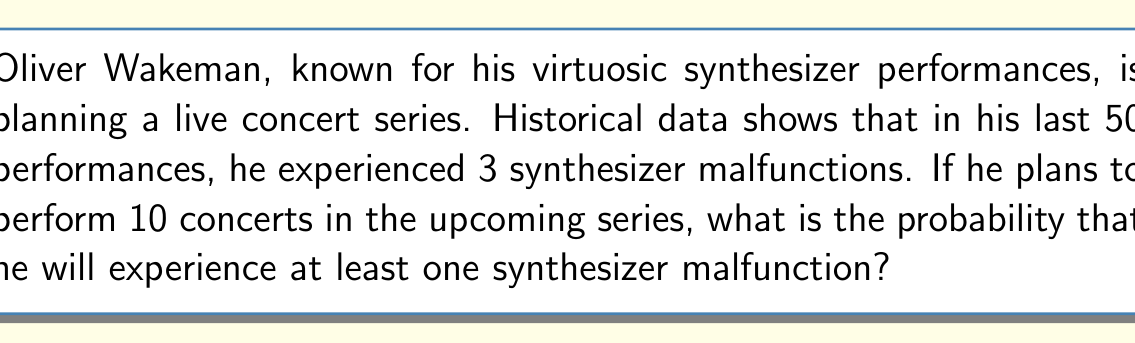Can you answer this question? Let's approach this step-by-step using the binomial probability distribution:

1) First, we need to calculate the probability of a malfunction in a single concert:
   $p = \frac{3}{50} = 0.06$

2) The probability of no malfunction in a single concert is:
   $1 - p = 1 - 0.06 = 0.94$

3) For 10 concerts, the probability of no malfunctions is:
   $P(\text{no malfunctions}) = (0.94)^{10}$

4) Therefore, the probability of at least one malfunction is:
   $P(\text{at least one malfunction}) = 1 - P(\text{no malfunctions})$
   $= 1 - (0.94)^{10}$

5) Let's calculate this:
   $1 - (0.94)^{10} = 1 - 0.5987 = 0.4013$

6) Converting to a percentage:
   $0.4013 \times 100\% = 40.13\%$
Answer: $40.13\%$ 